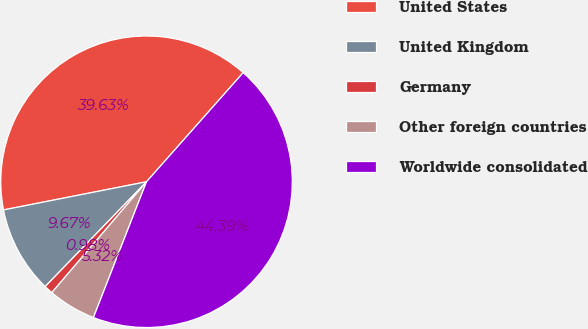<chart> <loc_0><loc_0><loc_500><loc_500><pie_chart><fcel>United States<fcel>United Kingdom<fcel>Germany<fcel>Other foreign countries<fcel>Worldwide consolidated<nl><fcel>39.63%<fcel>9.67%<fcel>0.98%<fcel>5.32%<fcel>44.39%<nl></chart> 